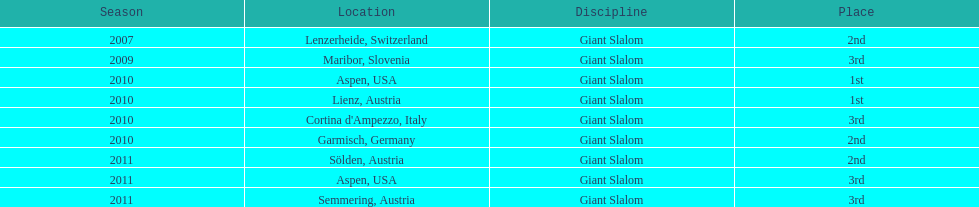What was the finishing place of the last race in december 2010? 3rd. 